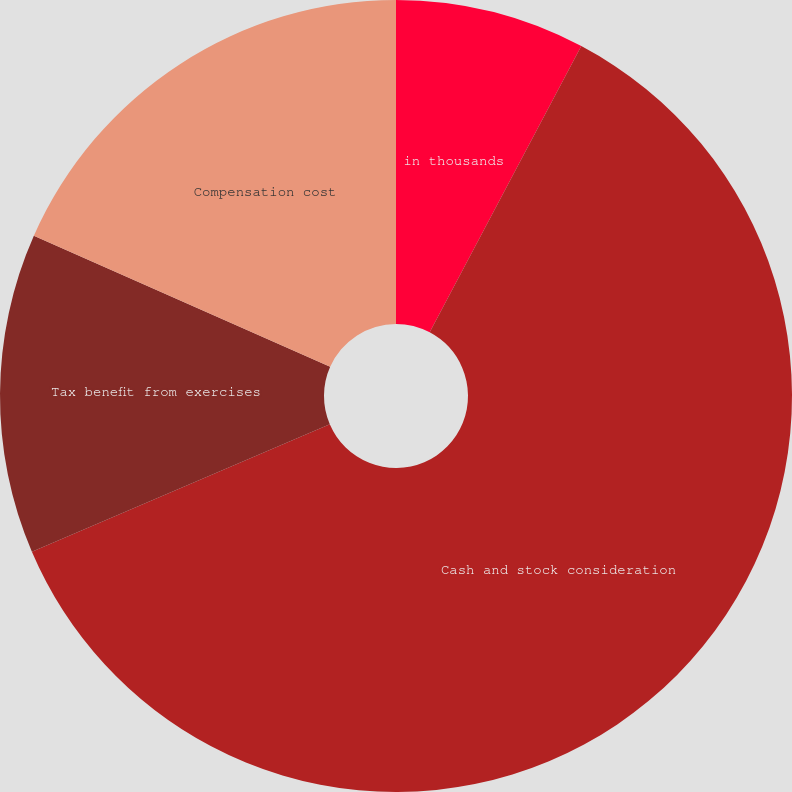Convert chart to OTSL. <chart><loc_0><loc_0><loc_500><loc_500><pie_chart><fcel>in thousands<fcel>Cash and stock consideration<fcel>Tax benefit from exercises<fcel>Compensation cost<nl><fcel>7.75%<fcel>60.82%<fcel>13.06%<fcel>18.37%<nl></chart> 